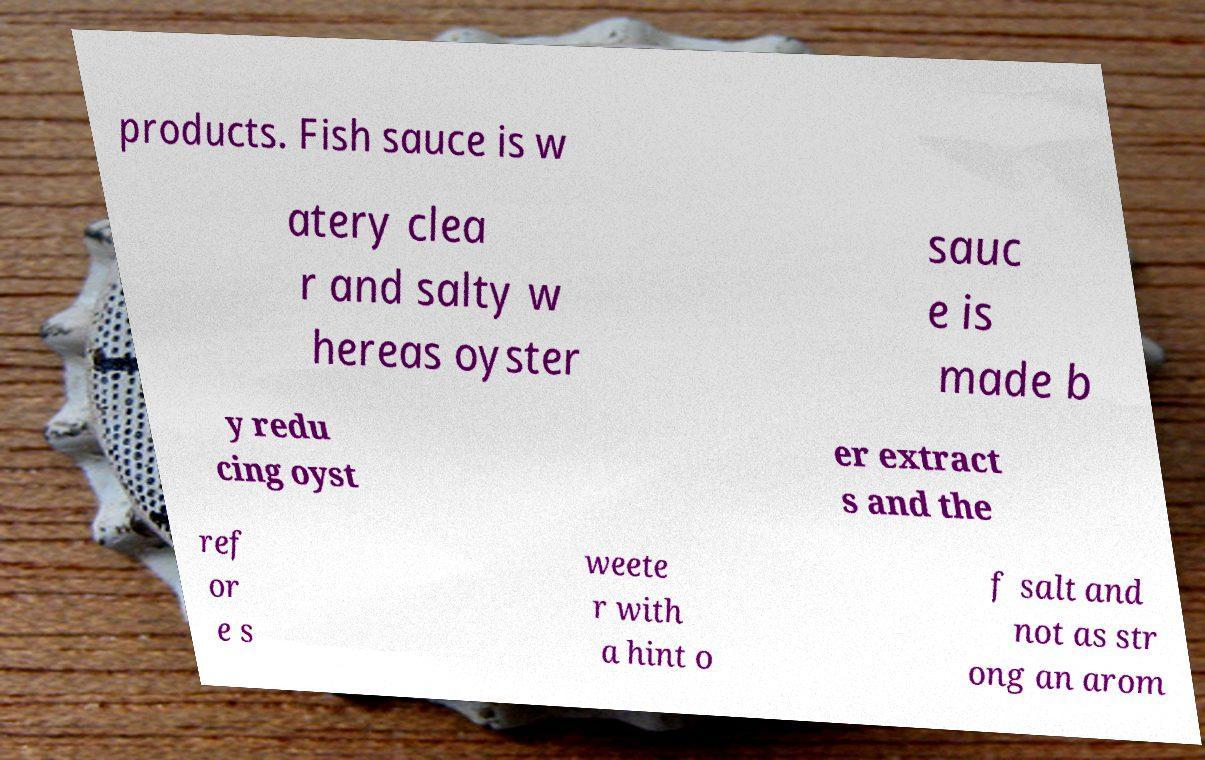Please identify and transcribe the text found in this image. products. Fish sauce is w atery clea r and salty w hereas oyster sauc e is made b y redu cing oyst er extract s and the ref or e s weete r with a hint o f salt and not as str ong an arom 